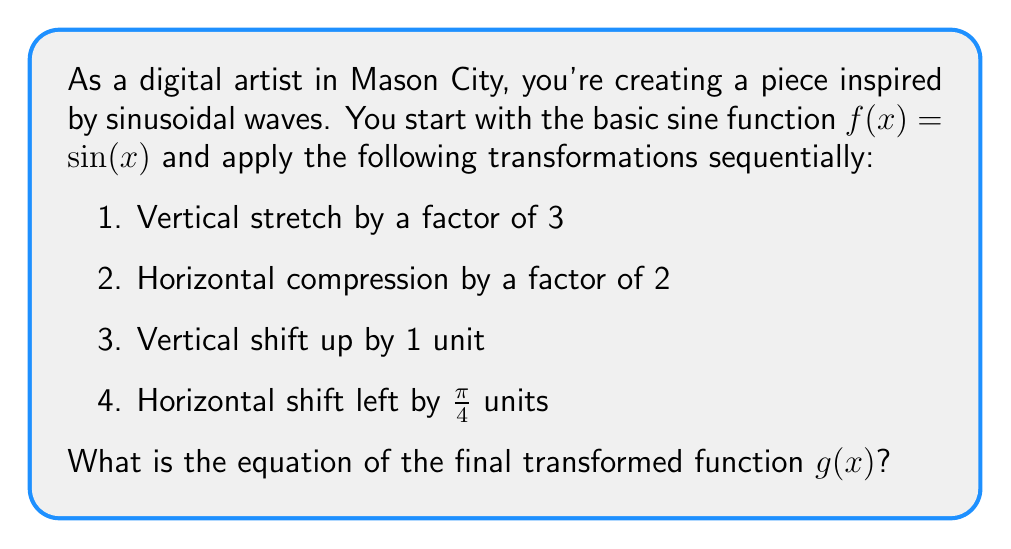Could you help me with this problem? Let's apply the transformations step by step:

1. Vertical stretch by a factor of 3:
   $f_1(x) = 3\sin(x)$

2. Horizontal compression by a factor of 2:
   $f_2(x) = 3\sin(2x)$
   (Note: Inside the parentheses, we multiply by 2 for compression)

3. Vertical shift up by 1 unit:
   $f_3(x) = 3\sin(2x) + 1$

4. Horizontal shift left by $\frac{\pi}{4}$ units:
   $g(x) = 3\sin(2(x + \frac{\pi}{4})) + 1$
   (Note: Inside the parentheses, we add $\frac{\pi}{4}$ for a left shift)

The final transformed function $g(x)$ combines all these transformations.
Answer: $g(x) = 3\sin(2(x + \frac{\pi}{4})) + 1$ 